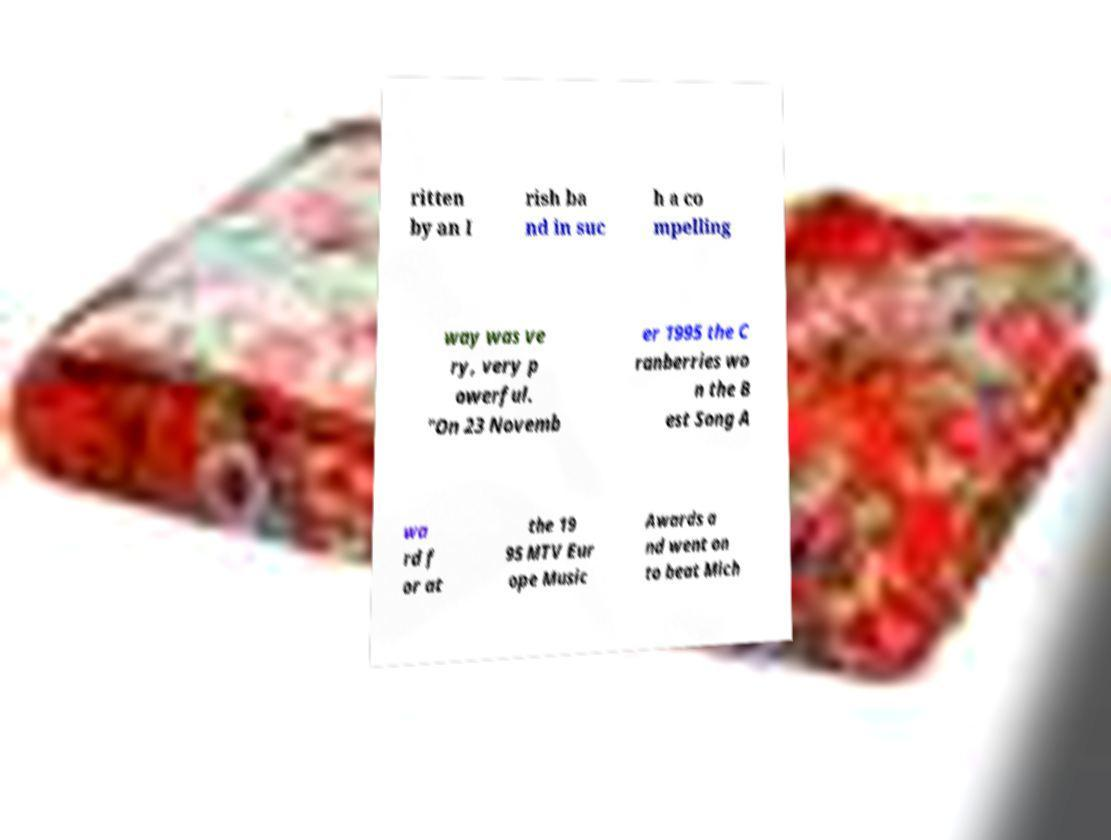There's text embedded in this image that I need extracted. Can you transcribe it verbatim? ritten by an I rish ba nd in suc h a co mpelling way was ve ry, very p owerful. "On 23 Novemb er 1995 the C ranberries wo n the B est Song A wa rd f or at the 19 95 MTV Eur ope Music Awards a nd went on to beat Mich 